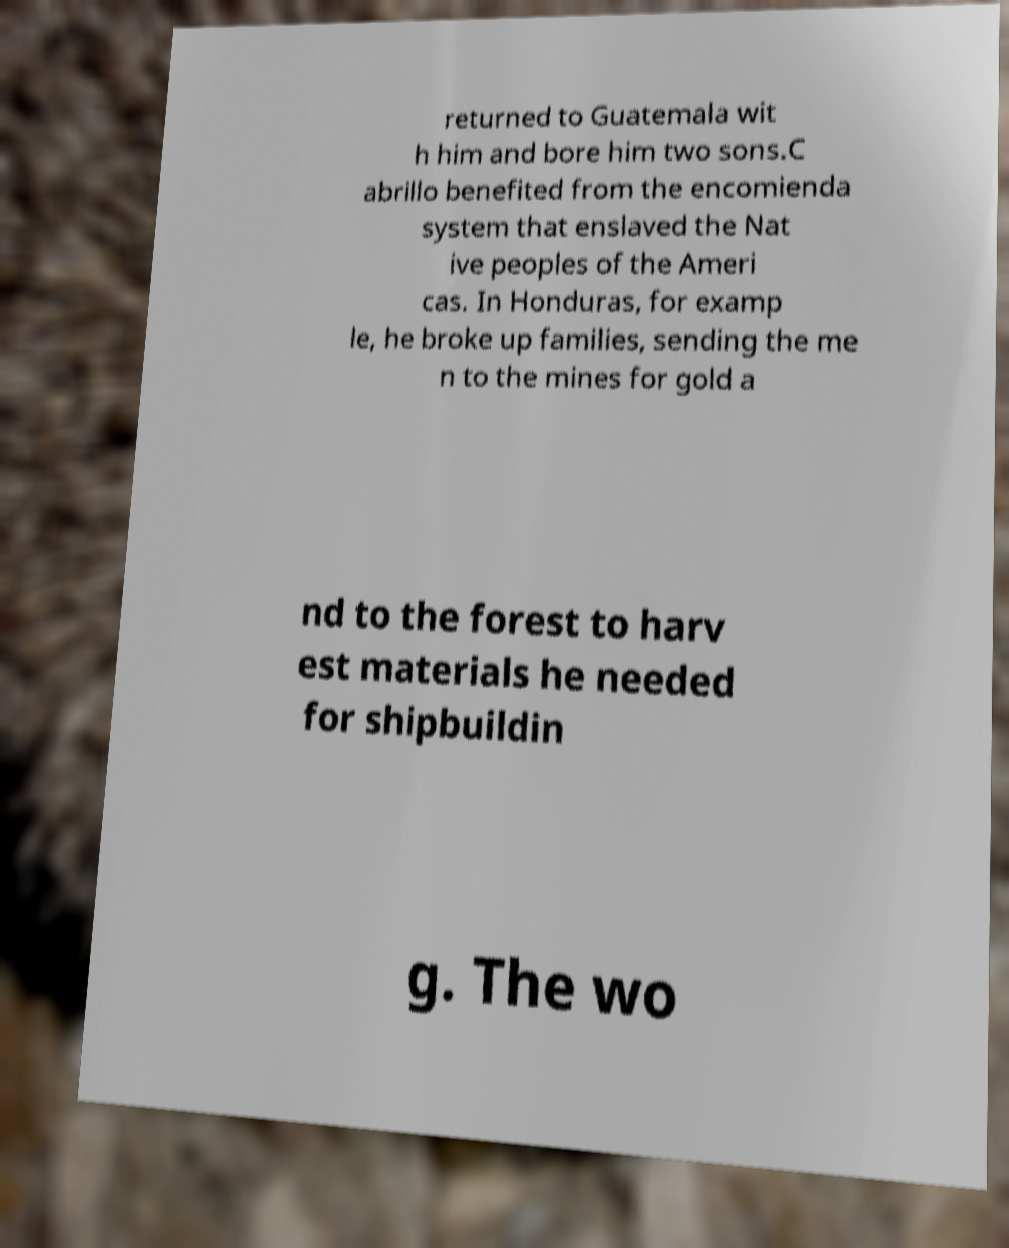Can you accurately transcribe the text from the provided image for me? returned to Guatemala wit h him and bore him two sons.C abrillo benefited from the encomienda system that enslaved the Nat ive peoples of the Ameri cas. In Honduras, for examp le, he broke up families, sending the me n to the mines for gold a nd to the forest to harv est materials he needed for shipbuildin g. The wo 